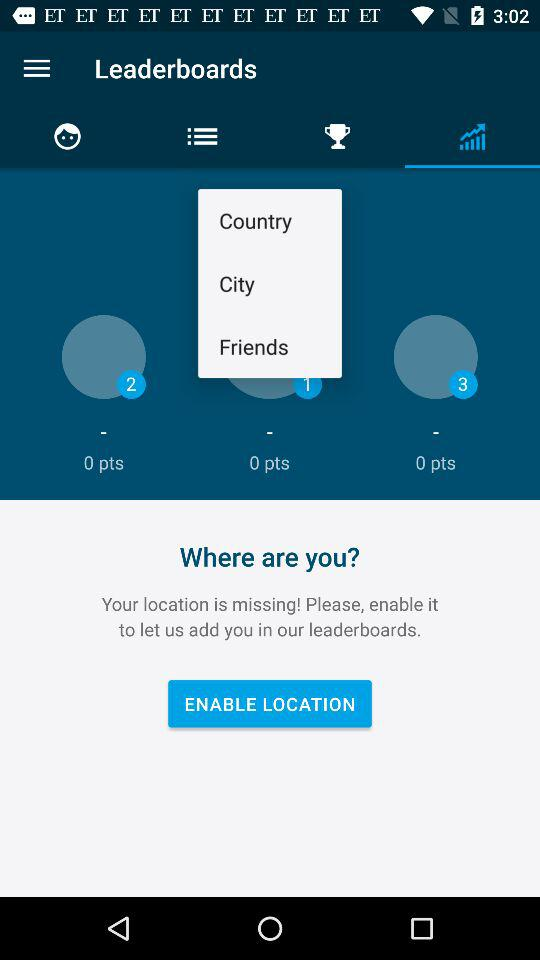Which tab is selected?
When the provided information is insufficient, respond with <no answer>. <no answer> 